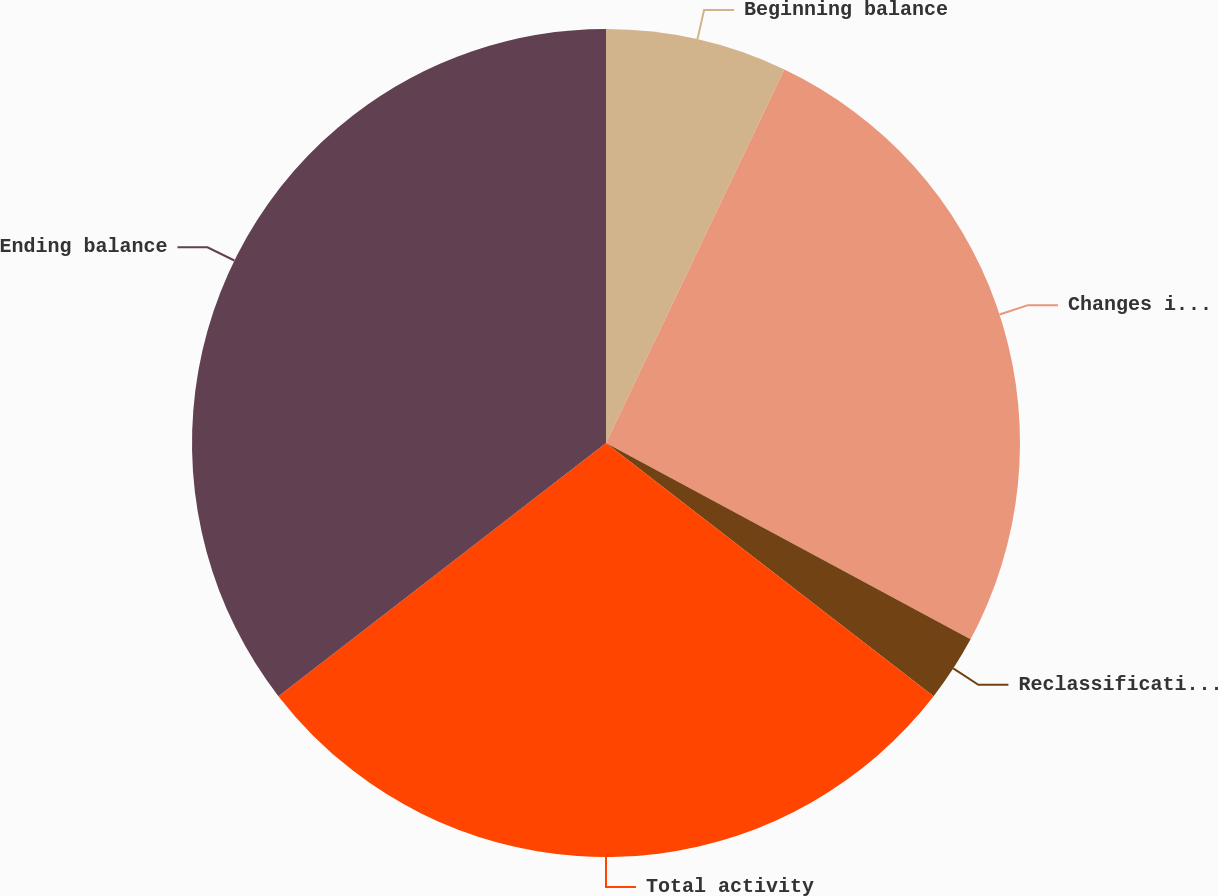Convert chart to OTSL. <chart><loc_0><loc_0><loc_500><loc_500><pie_chart><fcel>Beginning balance<fcel>Changes in fair value of<fcel>Reclassifications to earnings<fcel>Total activity<fcel>Ending balance<nl><fcel>7.09%<fcel>25.77%<fcel>2.61%<fcel>29.06%<fcel>35.47%<nl></chart> 